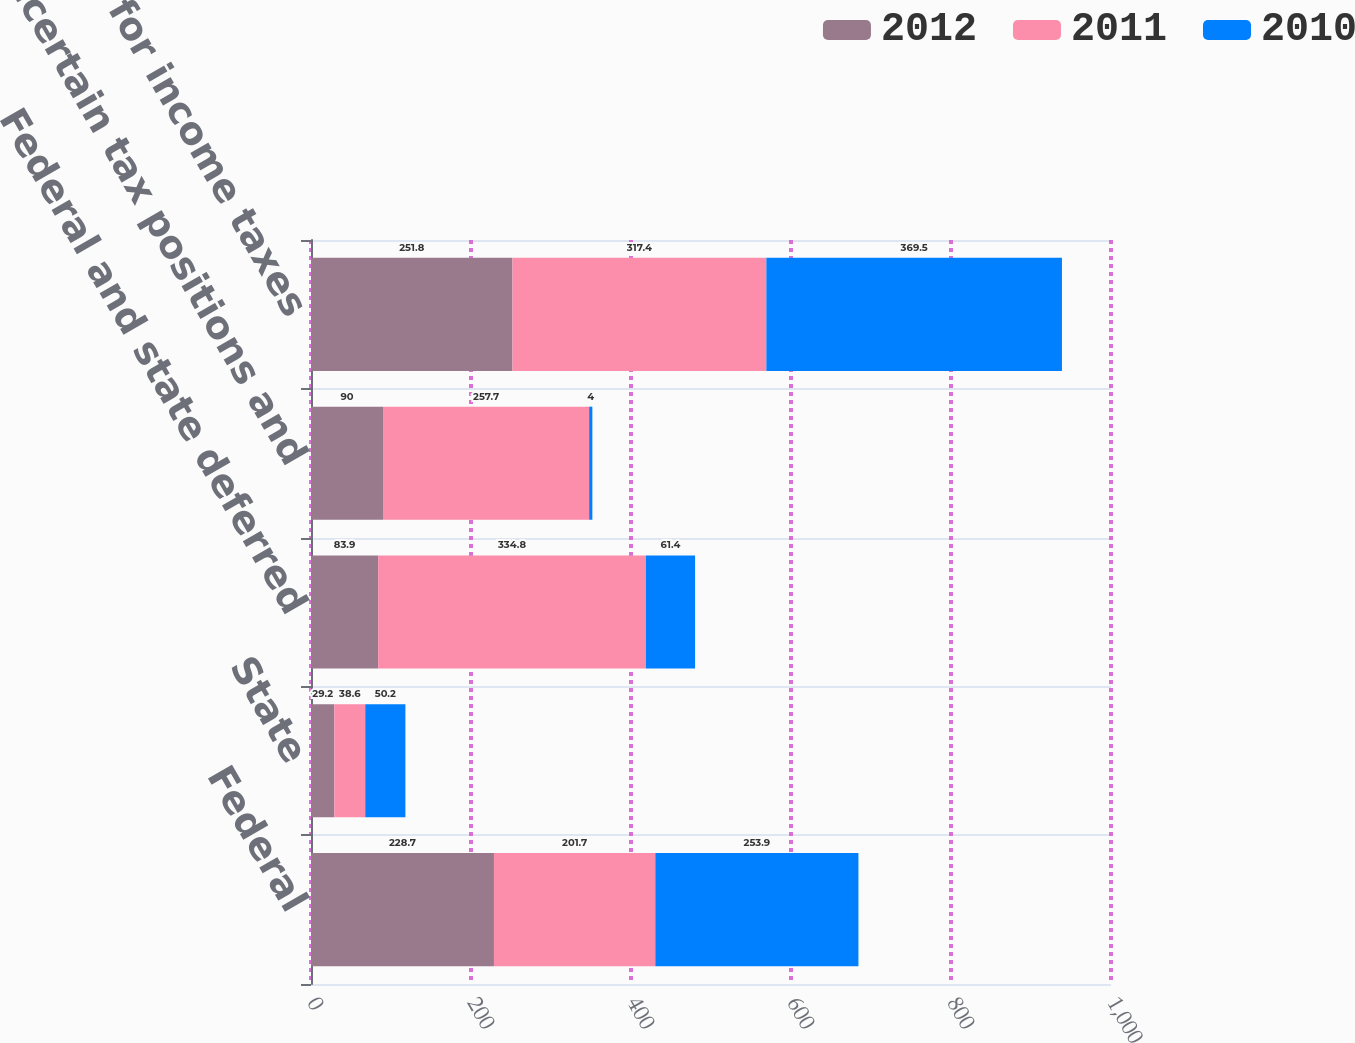Convert chart. <chart><loc_0><loc_0><loc_500><loc_500><stacked_bar_chart><ecel><fcel>Federal<fcel>State<fcel>Federal and state deferred<fcel>Uncertain tax positions and<fcel>Provision for income taxes<nl><fcel>2012<fcel>228.7<fcel>29.2<fcel>83.9<fcel>90<fcel>251.8<nl><fcel>2011<fcel>201.7<fcel>38.6<fcel>334.8<fcel>257.7<fcel>317.4<nl><fcel>2010<fcel>253.9<fcel>50.2<fcel>61.4<fcel>4<fcel>369.5<nl></chart> 